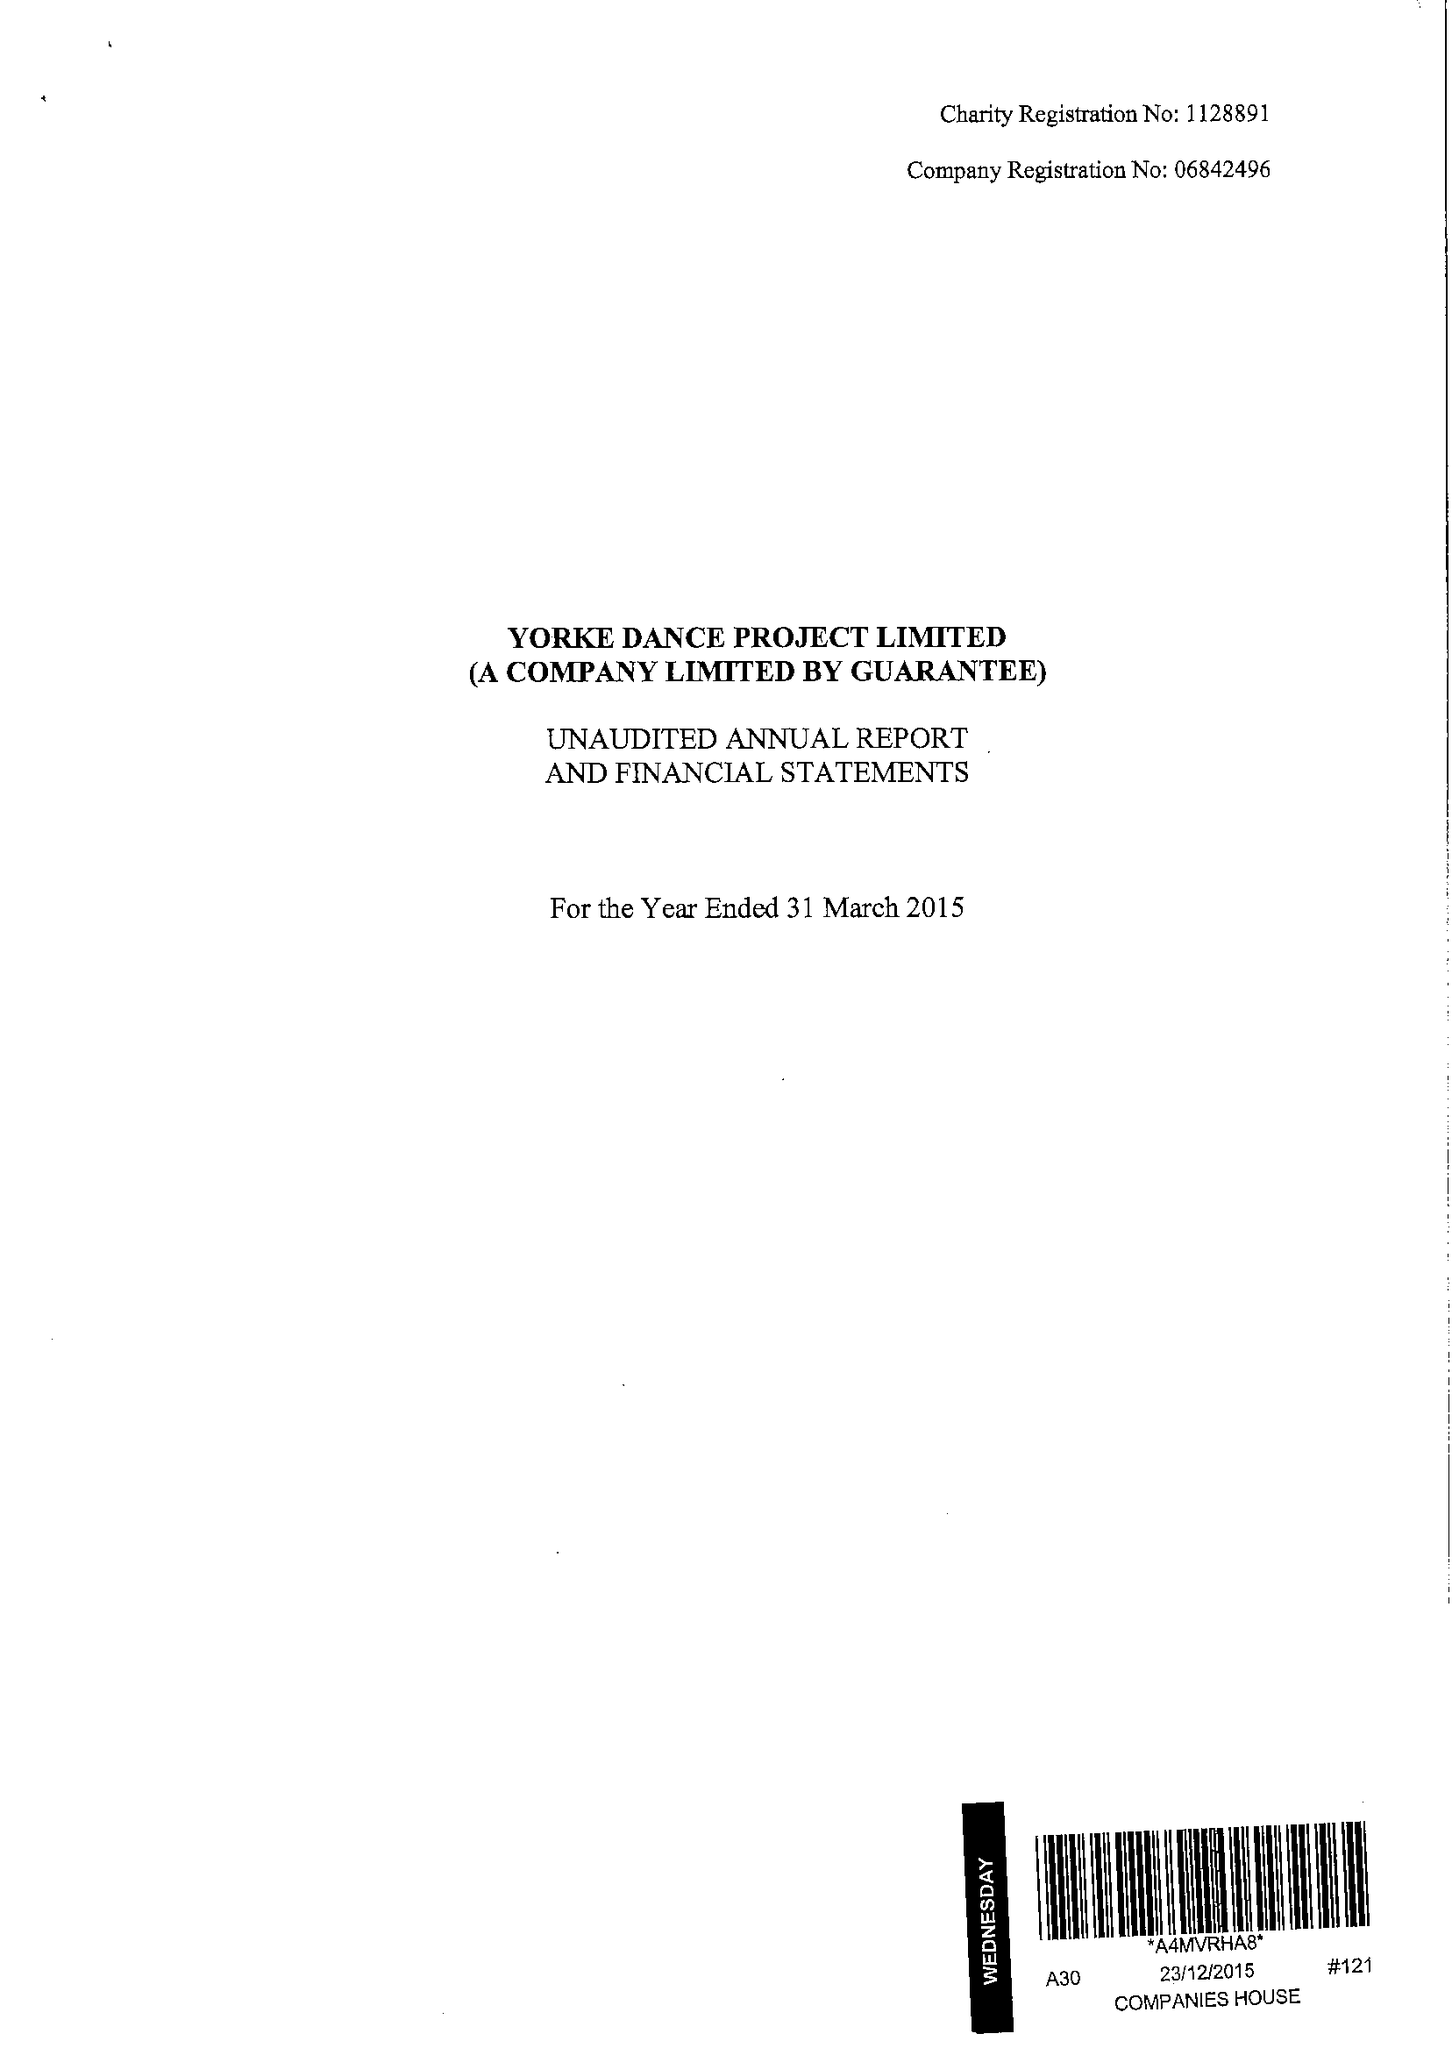What is the value for the address__street_line?
Answer the question using a single word or phrase. 28 RANELAGH AVENUE 